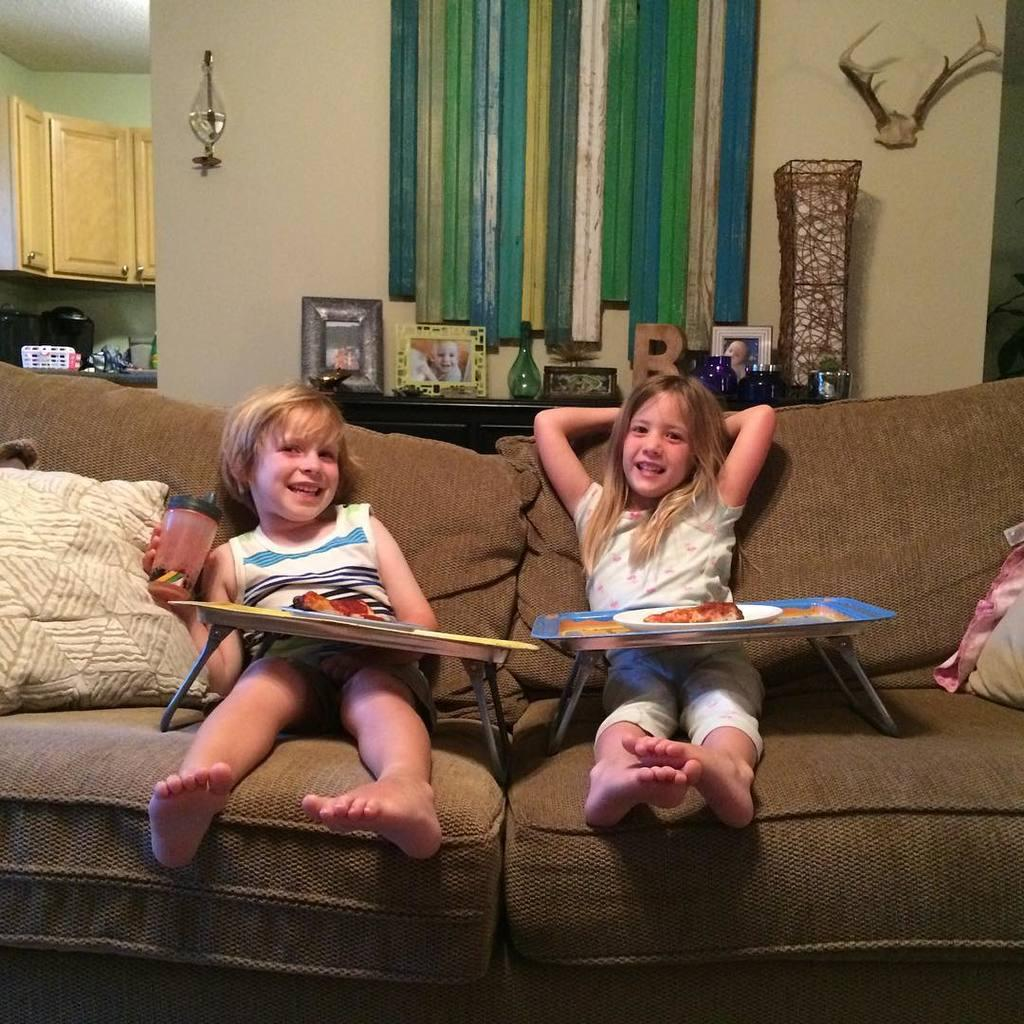How many kids are sitting on the sofa in the image? There are two kids sitting on the sofa in the image. What object can be seen on the sofa with the kids? There is a pillow in the image. What object is visible on the sofa that is not a pillow or a kid? There is a plate in the image. What can be seen in the background of the image? There is a wall in the background of the image, with frames on it. What type of furniture is visible in the background of the image? There is a cupboard in the background of the image. What type of cabbage is being used as a pillow by the kids in the image? There is no cabbage present in the image; the pillow is a separate object. How many pigs are visible in the image? There are no pigs present in the image. 